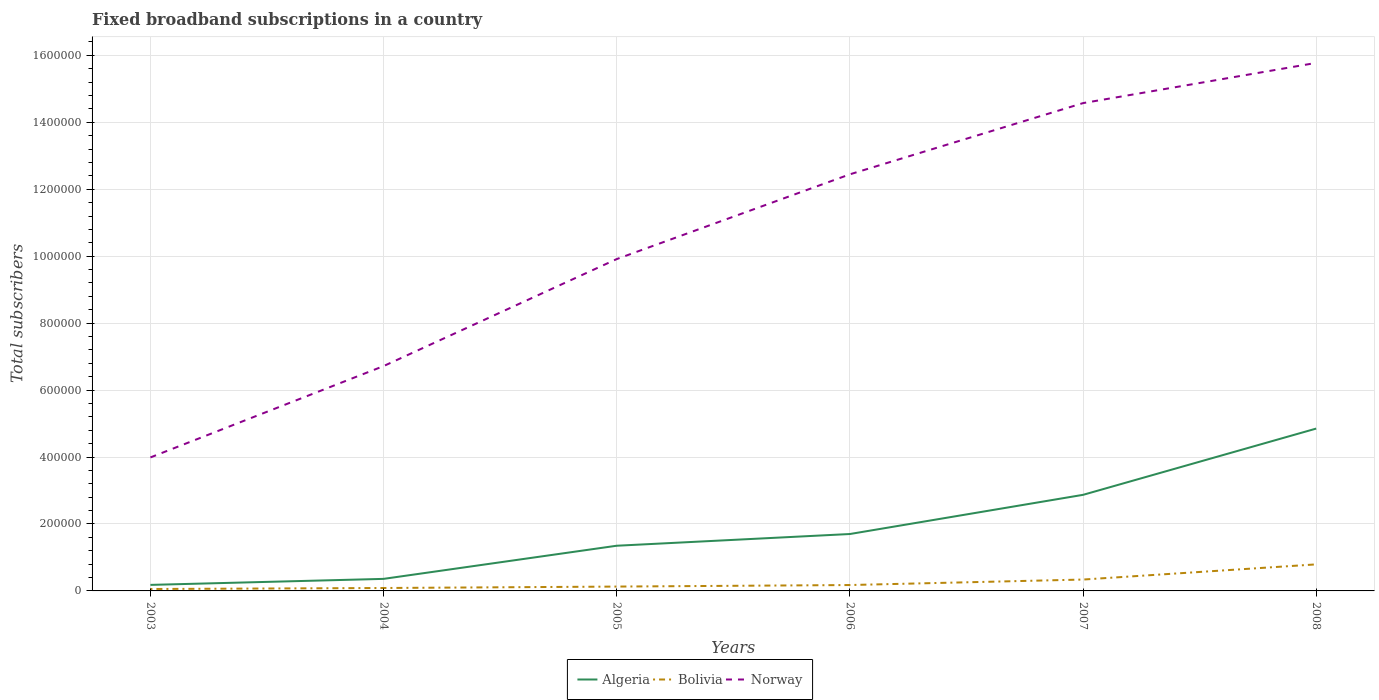Is the number of lines equal to the number of legend labels?
Give a very brief answer. Yes. Across all years, what is the maximum number of broadband subscriptions in Bolivia?
Provide a succinct answer. 5740. What is the total number of broadband subscriptions in Bolivia in the graph?
Provide a short and direct response. -1.18e+04. What is the difference between the highest and the second highest number of broadband subscriptions in Norway?
Provide a succinct answer. 1.18e+06. What is the difference between the highest and the lowest number of broadband subscriptions in Algeria?
Make the answer very short. 2. Is the number of broadband subscriptions in Norway strictly greater than the number of broadband subscriptions in Algeria over the years?
Ensure brevity in your answer.  No. How many years are there in the graph?
Your response must be concise. 6. What is the difference between two consecutive major ticks on the Y-axis?
Ensure brevity in your answer.  2.00e+05. Are the values on the major ticks of Y-axis written in scientific E-notation?
Ensure brevity in your answer.  No. Where does the legend appear in the graph?
Make the answer very short. Bottom center. What is the title of the graph?
Offer a terse response. Fixed broadband subscriptions in a country. What is the label or title of the X-axis?
Keep it short and to the point. Years. What is the label or title of the Y-axis?
Your response must be concise. Total subscribers. What is the Total subscribers of Algeria in 2003?
Ensure brevity in your answer.  1.80e+04. What is the Total subscribers of Bolivia in 2003?
Your response must be concise. 5740. What is the Total subscribers in Norway in 2003?
Your answer should be very brief. 3.99e+05. What is the Total subscribers in Algeria in 2004?
Ensure brevity in your answer.  3.60e+04. What is the Total subscribers of Bolivia in 2004?
Give a very brief answer. 8723. What is the Total subscribers of Norway in 2004?
Your answer should be very brief. 6.72e+05. What is the Total subscribers in Algeria in 2005?
Provide a short and direct response. 1.35e+05. What is the Total subscribers of Bolivia in 2005?
Ensure brevity in your answer.  1.30e+04. What is the Total subscribers in Norway in 2005?
Make the answer very short. 9.91e+05. What is the Total subscribers in Algeria in 2006?
Provide a succinct answer. 1.70e+05. What is the Total subscribers of Bolivia in 2006?
Provide a short and direct response. 1.76e+04. What is the Total subscribers of Norway in 2006?
Make the answer very short. 1.24e+06. What is the Total subscribers of Algeria in 2007?
Ensure brevity in your answer.  2.87e+05. What is the Total subscribers of Bolivia in 2007?
Make the answer very short. 3.40e+04. What is the Total subscribers in Norway in 2007?
Your answer should be very brief. 1.46e+06. What is the Total subscribers of Algeria in 2008?
Your response must be concise. 4.85e+05. What is the Total subscribers in Bolivia in 2008?
Keep it short and to the point. 7.93e+04. What is the Total subscribers in Norway in 2008?
Ensure brevity in your answer.  1.58e+06. Across all years, what is the maximum Total subscribers in Algeria?
Your answer should be compact. 4.85e+05. Across all years, what is the maximum Total subscribers in Bolivia?
Your answer should be compact. 7.93e+04. Across all years, what is the maximum Total subscribers of Norway?
Your answer should be very brief. 1.58e+06. Across all years, what is the minimum Total subscribers of Algeria?
Ensure brevity in your answer.  1.80e+04. Across all years, what is the minimum Total subscribers of Bolivia?
Your response must be concise. 5740. Across all years, what is the minimum Total subscribers of Norway?
Your answer should be compact. 3.99e+05. What is the total Total subscribers of Algeria in the graph?
Provide a short and direct response. 1.13e+06. What is the total Total subscribers in Bolivia in the graph?
Your answer should be compact. 1.58e+05. What is the total Total subscribers in Norway in the graph?
Your answer should be compact. 6.34e+06. What is the difference between the Total subscribers of Algeria in 2003 and that in 2004?
Keep it short and to the point. -1.80e+04. What is the difference between the Total subscribers of Bolivia in 2003 and that in 2004?
Give a very brief answer. -2983. What is the difference between the Total subscribers in Norway in 2003 and that in 2004?
Your answer should be very brief. -2.73e+05. What is the difference between the Total subscribers in Algeria in 2003 and that in 2005?
Your response must be concise. -1.17e+05. What is the difference between the Total subscribers of Bolivia in 2003 and that in 2005?
Provide a succinct answer. -7233. What is the difference between the Total subscribers of Norway in 2003 and that in 2005?
Give a very brief answer. -5.93e+05. What is the difference between the Total subscribers of Algeria in 2003 and that in 2006?
Provide a short and direct response. -1.52e+05. What is the difference between the Total subscribers in Bolivia in 2003 and that in 2006?
Provide a succinct answer. -1.18e+04. What is the difference between the Total subscribers of Norway in 2003 and that in 2006?
Provide a short and direct response. -8.46e+05. What is the difference between the Total subscribers of Algeria in 2003 and that in 2007?
Ensure brevity in your answer.  -2.69e+05. What is the difference between the Total subscribers in Bolivia in 2003 and that in 2007?
Provide a succinct answer. -2.82e+04. What is the difference between the Total subscribers in Norway in 2003 and that in 2007?
Offer a terse response. -1.06e+06. What is the difference between the Total subscribers in Algeria in 2003 and that in 2008?
Give a very brief answer. -4.67e+05. What is the difference between the Total subscribers of Bolivia in 2003 and that in 2008?
Your answer should be very brief. -7.36e+04. What is the difference between the Total subscribers in Norway in 2003 and that in 2008?
Keep it short and to the point. -1.18e+06. What is the difference between the Total subscribers in Algeria in 2004 and that in 2005?
Make the answer very short. -9.90e+04. What is the difference between the Total subscribers in Bolivia in 2004 and that in 2005?
Ensure brevity in your answer.  -4250. What is the difference between the Total subscribers of Norway in 2004 and that in 2005?
Your answer should be compact. -3.20e+05. What is the difference between the Total subscribers of Algeria in 2004 and that in 2006?
Offer a very short reply. -1.34e+05. What is the difference between the Total subscribers in Bolivia in 2004 and that in 2006?
Give a very brief answer. -8866. What is the difference between the Total subscribers of Norway in 2004 and that in 2006?
Keep it short and to the point. -5.73e+05. What is the difference between the Total subscribers in Algeria in 2004 and that in 2007?
Ensure brevity in your answer.  -2.51e+05. What is the difference between the Total subscribers in Bolivia in 2004 and that in 2007?
Ensure brevity in your answer.  -2.53e+04. What is the difference between the Total subscribers of Norway in 2004 and that in 2007?
Provide a short and direct response. -7.86e+05. What is the difference between the Total subscribers in Algeria in 2004 and that in 2008?
Provide a succinct answer. -4.49e+05. What is the difference between the Total subscribers in Bolivia in 2004 and that in 2008?
Provide a short and direct response. -7.06e+04. What is the difference between the Total subscribers in Norway in 2004 and that in 2008?
Your response must be concise. -9.06e+05. What is the difference between the Total subscribers of Algeria in 2005 and that in 2006?
Make the answer very short. -3.50e+04. What is the difference between the Total subscribers of Bolivia in 2005 and that in 2006?
Your answer should be very brief. -4616. What is the difference between the Total subscribers in Norway in 2005 and that in 2006?
Your answer should be compact. -2.53e+05. What is the difference between the Total subscribers of Algeria in 2005 and that in 2007?
Keep it short and to the point. -1.52e+05. What is the difference between the Total subscribers of Bolivia in 2005 and that in 2007?
Your answer should be compact. -2.10e+04. What is the difference between the Total subscribers of Norway in 2005 and that in 2007?
Give a very brief answer. -4.66e+05. What is the difference between the Total subscribers of Algeria in 2005 and that in 2008?
Your answer should be compact. -3.50e+05. What is the difference between the Total subscribers of Bolivia in 2005 and that in 2008?
Offer a terse response. -6.63e+04. What is the difference between the Total subscribers in Norway in 2005 and that in 2008?
Offer a very short reply. -5.86e+05. What is the difference between the Total subscribers in Algeria in 2006 and that in 2007?
Make the answer very short. -1.17e+05. What is the difference between the Total subscribers of Bolivia in 2006 and that in 2007?
Your response must be concise. -1.64e+04. What is the difference between the Total subscribers in Norway in 2006 and that in 2007?
Make the answer very short. -2.13e+05. What is the difference between the Total subscribers of Algeria in 2006 and that in 2008?
Offer a very short reply. -3.15e+05. What is the difference between the Total subscribers in Bolivia in 2006 and that in 2008?
Make the answer very short. -6.17e+04. What is the difference between the Total subscribers in Norway in 2006 and that in 2008?
Provide a short and direct response. -3.33e+05. What is the difference between the Total subscribers of Algeria in 2007 and that in 2008?
Ensure brevity in your answer.  -1.98e+05. What is the difference between the Total subscribers of Bolivia in 2007 and that in 2008?
Keep it short and to the point. -4.53e+04. What is the difference between the Total subscribers in Norway in 2007 and that in 2008?
Keep it short and to the point. -1.20e+05. What is the difference between the Total subscribers in Algeria in 2003 and the Total subscribers in Bolivia in 2004?
Your answer should be compact. 9277. What is the difference between the Total subscribers in Algeria in 2003 and the Total subscribers in Norway in 2004?
Offer a terse response. -6.54e+05. What is the difference between the Total subscribers of Bolivia in 2003 and the Total subscribers of Norway in 2004?
Your answer should be compact. -6.66e+05. What is the difference between the Total subscribers of Algeria in 2003 and the Total subscribers of Bolivia in 2005?
Offer a very short reply. 5027. What is the difference between the Total subscribers in Algeria in 2003 and the Total subscribers in Norway in 2005?
Give a very brief answer. -9.73e+05. What is the difference between the Total subscribers of Bolivia in 2003 and the Total subscribers of Norway in 2005?
Provide a succinct answer. -9.86e+05. What is the difference between the Total subscribers of Algeria in 2003 and the Total subscribers of Bolivia in 2006?
Keep it short and to the point. 411. What is the difference between the Total subscribers in Algeria in 2003 and the Total subscribers in Norway in 2006?
Offer a very short reply. -1.23e+06. What is the difference between the Total subscribers in Bolivia in 2003 and the Total subscribers in Norway in 2006?
Your answer should be very brief. -1.24e+06. What is the difference between the Total subscribers in Algeria in 2003 and the Total subscribers in Bolivia in 2007?
Provide a short and direct response. -1.60e+04. What is the difference between the Total subscribers in Algeria in 2003 and the Total subscribers in Norway in 2007?
Give a very brief answer. -1.44e+06. What is the difference between the Total subscribers in Bolivia in 2003 and the Total subscribers in Norway in 2007?
Your response must be concise. -1.45e+06. What is the difference between the Total subscribers in Algeria in 2003 and the Total subscribers in Bolivia in 2008?
Offer a terse response. -6.13e+04. What is the difference between the Total subscribers in Algeria in 2003 and the Total subscribers in Norway in 2008?
Your answer should be compact. -1.56e+06. What is the difference between the Total subscribers of Bolivia in 2003 and the Total subscribers of Norway in 2008?
Ensure brevity in your answer.  -1.57e+06. What is the difference between the Total subscribers in Algeria in 2004 and the Total subscribers in Bolivia in 2005?
Offer a terse response. 2.30e+04. What is the difference between the Total subscribers of Algeria in 2004 and the Total subscribers of Norway in 2005?
Offer a terse response. -9.55e+05. What is the difference between the Total subscribers of Bolivia in 2004 and the Total subscribers of Norway in 2005?
Keep it short and to the point. -9.83e+05. What is the difference between the Total subscribers of Algeria in 2004 and the Total subscribers of Bolivia in 2006?
Offer a very short reply. 1.84e+04. What is the difference between the Total subscribers of Algeria in 2004 and the Total subscribers of Norway in 2006?
Make the answer very short. -1.21e+06. What is the difference between the Total subscribers in Bolivia in 2004 and the Total subscribers in Norway in 2006?
Offer a very short reply. -1.24e+06. What is the difference between the Total subscribers of Algeria in 2004 and the Total subscribers of Bolivia in 2007?
Your response must be concise. 2023. What is the difference between the Total subscribers in Algeria in 2004 and the Total subscribers in Norway in 2007?
Keep it short and to the point. -1.42e+06. What is the difference between the Total subscribers of Bolivia in 2004 and the Total subscribers of Norway in 2007?
Offer a very short reply. -1.45e+06. What is the difference between the Total subscribers in Algeria in 2004 and the Total subscribers in Bolivia in 2008?
Offer a very short reply. -4.33e+04. What is the difference between the Total subscribers in Algeria in 2004 and the Total subscribers in Norway in 2008?
Your answer should be very brief. -1.54e+06. What is the difference between the Total subscribers of Bolivia in 2004 and the Total subscribers of Norway in 2008?
Provide a succinct answer. -1.57e+06. What is the difference between the Total subscribers of Algeria in 2005 and the Total subscribers of Bolivia in 2006?
Give a very brief answer. 1.17e+05. What is the difference between the Total subscribers in Algeria in 2005 and the Total subscribers in Norway in 2006?
Make the answer very short. -1.11e+06. What is the difference between the Total subscribers in Bolivia in 2005 and the Total subscribers in Norway in 2006?
Keep it short and to the point. -1.23e+06. What is the difference between the Total subscribers of Algeria in 2005 and the Total subscribers of Bolivia in 2007?
Your response must be concise. 1.01e+05. What is the difference between the Total subscribers of Algeria in 2005 and the Total subscribers of Norway in 2007?
Give a very brief answer. -1.32e+06. What is the difference between the Total subscribers of Bolivia in 2005 and the Total subscribers of Norway in 2007?
Your answer should be very brief. -1.44e+06. What is the difference between the Total subscribers in Algeria in 2005 and the Total subscribers in Bolivia in 2008?
Ensure brevity in your answer.  5.57e+04. What is the difference between the Total subscribers of Algeria in 2005 and the Total subscribers of Norway in 2008?
Provide a short and direct response. -1.44e+06. What is the difference between the Total subscribers of Bolivia in 2005 and the Total subscribers of Norway in 2008?
Ensure brevity in your answer.  -1.56e+06. What is the difference between the Total subscribers of Algeria in 2006 and the Total subscribers of Bolivia in 2007?
Give a very brief answer. 1.36e+05. What is the difference between the Total subscribers of Algeria in 2006 and the Total subscribers of Norway in 2007?
Give a very brief answer. -1.29e+06. What is the difference between the Total subscribers in Bolivia in 2006 and the Total subscribers in Norway in 2007?
Keep it short and to the point. -1.44e+06. What is the difference between the Total subscribers of Algeria in 2006 and the Total subscribers of Bolivia in 2008?
Your answer should be very brief. 9.07e+04. What is the difference between the Total subscribers of Algeria in 2006 and the Total subscribers of Norway in 2008?
Your answer should be very brief. -1.41e+06. What is the difference between the Total subscribers of Bolivia in 2006 and the Total subscribers of Norway in 2008?
Your answer should be very brief. -1.56e+06. What is the difference between the Total subscribers of Algeria in 2007 and the Total subscribers of Bolivia in 2008?
Keep it short and to the point. 2.08e+05. What is the difference between the Total subscribers in Algeria in 2007 and the Total subscribers in Norway in 2008?
Keep it short and to the point. -1.29e+06. What is the difference between the Total subscribers in Bolivia in 2007 and the Total subscribers in Norway in 2008?
Provide a succinct answer. -1.54e+06. What is the average Total subscribers in Algeria per year?
Provide a succinct answer. 1.89e+05. What is the average Total subscribers in Bolivia per year?
Make the answer very short. 2.64e+04. What is the average Total subscribers in Norway per year?
Keep it short and to the point. 1.06e+06. In the year 2003, what is the difference between the Total subscribers of Algeria and Total subscribers of Bolivia?
Offer a very short reply. 1.23e+04. In the year 2003, what is the difference between the Total subscribers of Algeria and Total subscribers of Norway?
Your response must be concise. -3.81e+05. In the year 2003, what is the difference between the Total subscribers of Bolivia and Total subscribers of Norway?
Offer a terse response. -3.93e+05. In the year 2004, what is the difference between the Total subscribers of Algeria and Total subscribers of Bolivia?
Your answer should be very brief. 2.73e+04. In the year 2004, what is the difference between the Total subscribers in Algeria and Total subscribers in Norway?
Your answer should be very brief. -6.36e+05. In the year 2004, what is the difference between the Total subscribers in Bolivia and Total subscribers in Norway?
Keep it short and to the point. -6.63e+05. In the year 2005, what is the difference between the Total subscribers in Algeria and Total subscribers in Bolivia?
Give a very brief answer. 1.22e+05. In the year 2005, what is the difference between the Total subscribers in Algeria and Total subscribers in Norway?
Ensure brevity in your answer.  -8.56e+05. In the year 2005, what is the difference between the Total subscribers in Bolivia and Total subscribers in Norway?
Provide a short and direct response. -9.78e+05. In the year 2006, what is the difference between the Total subscribers of Algeria and Total subscribers of Bolivia?
Make the answer very short. 1.52e+05. In the year 2006, what is the difference between the Total subscribers in Algeria and Total subscribers in Norway?
Your answer should be very brief. -1.07e+06. In the year 2006, what is the difference between the Total subscribers in Bolivia and Total subscribers in Norway?
Your answer should be compact. -1.23e+06. In the year 2007, what is the difference between the Total subscribers in Algeria and Total subscribers in Bolivia?
Your response must be concise. 2.53e+05. In the year 2007, what is the difference between the Total subscribers of Algeria and Total subscribers of Norway?
Your response must be concise. -1.17e+06. In the year 2007, what is the difference between the Total subscribers in Bolivia and Total subscribers in Norway?
Provide a short and direct response. -1.42e+06. In the year 2008, what is the difference between the Total subscribers in Algeria and Total subscribers in Bolivia?
Make the answer very short. 4.06e+05. In the year 2008, what is the difference between the Total subscribers of Algeria and Total subscribers of Norway?
Offer a terse response. -1.09e+06. In the year 2008, what is the difference between the Total subscribers of Bolivia and Total subscribers of Norway?
Your response must be concise. -1.50e+06. What is the ratio of the Total subscribers in Algeria in 2003 to that in 2004?
Your answer should be very brief. 0.5. What is the ratio of the Total subscribers of Bolivia in 2003 to that in 2004?
Offer a very short reply. 0.66. What is the ratio of the Total subscribers in Norway in 2003 to that in 2004?
Ensure brevity in your answer.  0.59. What is the ratio of the Total subscribers in Algeria in 2003 to that in 2005?
Give a very brief answer. 0.13. What is the ratio of the Total subscribers in Bolivia in 2003 to that in 2005?
Your answer should be compact. 0.44. What is the ratio of the Total subscribers of Norway in 2003 to that in 2005?
Ensure brevity in your answer.  0.4. What is the ratio of the Total subscribers of Algeria in 2003 to that in 2006?
Offer a very short reply. 0.11. What is the ratio of the Total subscribers in Bolivia in 2003 to that in 2006?
Offer a terse response. 0.33. What is the ratio of the Total subscribers in Norway in 2003 to that in 2006?
Your response must be concise. 0.32. What is the ratio of the Total subscribers in Algeria in 2003 to that in 2007?
Keep it short and to the point. 0.06. What is the ratio of the Total subscribers in Bolivia in 2003 to that in 2007?
Your answer should be very brief. 0.17. What is the ratio of the Total subscribers of Norway in 2003 to that in 2007?
Your answer should be very brief. 0.27. What is the ratio of the Total subscribers of Algeria in 2003 to that in 2008?
Give a very brief answer. 0.04. What is the ratio of the Total subscribers in Bolivia in 2003 to that in 2008?
Provide a short and direct response. 0.07. What is the ratio of the Total subscribers in Norway in 2003 to that in 2008?
Your answer should be compact. 0.25. What is the ratio of the Total subscribers in Algeria in 2004 to that in 2005?
Make the answer very short. 0.27. What is the ratio of the Total subscribers of Bolivia in 2004 to that in 2005?
Provide a succinct answer. 0.67. What is the ratio of the Total subscribers in Norway in 2004 to that in 2005?
Provide a succinct answer. 0.68. What is the ratio of the Total subscribers of Algeria in 2004 to that in 2006?
Keep it short and to the point. 0.21. What is the ratio of the Total subscribers in Bolivia in 2004 to that in 2006?
Your answer should be compact. 0.5. What is the ratio of the Total subscribers in Norway in 2004 to that in 2006?
Ensure brevity in your answer.  0.54. What is the ratio of the Total subscribers in Algeria in 2004 to that in 2007?
Offer a terse response. 0.13. What is the ratio of the Total subscribers in Bolivia in 2004 to that in 2007?
Your response must be concise. 0.26. What is the ratio of the Total subscribers of Norway in 2004 to that in 2007?
Your answer should be compact. 0.46. What is the ratio of the Total subscribers in Algeria in 2004 to that in 2008?
Provide a succinct answer. 0.07. What is the ratio of the Total subscribers in Bolivia in 2004 to that in 2008?
Offer a terse response. 0.11. What is the ratio of the Total subscribers in Norway in 2004 to that in 2008?
Your response must be concise. 0.43. What is the ratio of the Total subscribers of Algeria in 2005 to that in 2006?
Keep it short and to the point. 0.79. What is the ratio of the Total subscribers in Bolivia in 2005 to that in 2006?
Make the answer very short. 0.74. What is the ratio of the Total subscribers in Norway in 2005 to that in 2006?
Give a very brief answer. 0.8. What is the ratio of the Total subscribers of Algeria in 2005 to that in 2007?
Provide a succinct answer. 0.47. What is the ratio of the Total subscribers in Bolivia in 2005 to that in 2007?
Your answer should be compact. 0.38. What is the ratio of the Total subscribers in Norway in 2005 to that in 2007?
Give a very brief answer. 0.68. What is the ratio of the Total subscribers in Algeria in 2005 to that in 2008?
Offer a very short reply. 0.28. What is the ratio of the Total subscribers of Bolivia in 2005 to that in 2008?
Give a very brief answer. 0.16. What is the ratio of the Total subscribers in Norway in 2005 to that in 2008?
Give a very brief answer. 0.63. What is the ratio of the Total subscribers of Algeria in 2006 to that in 2007?
Your response must be concise. 0.59. What is the ratio of the Total subscribers of Bolivia in 2006 to that in 2007?
Your answer should be compact. 0.52. What is the ratio of the Total subscribers in Norway in 2006 to that in 2007?
Offer a very short reply. 0.85. What is the ratio of the Total subscribers in Algeria in 2006 to that in 2008?
Offer a terse response. 0.35. What is the ratio of the Total subscribers in Bolivia in 2006 to that in 2008?
Your response must be concise. 0.22. What is the ratio of the Total subscribers of Norway in 2006 to that in 2008?
Your answer should be compact. 0.79. What is the ratio of the Total subscribers of Algeria in 2007 to that in 2008?
Your answer should be very brief. 0.59. What is the ratio of the Total subscribers of Bolivia in 2007 to that in 2008?
Provide a short and direct response. 0.43. What is the ratio of the Total subscribers in Norway in 2007 to that in 2008?
Ensure brevity in your answer.  0.92. What is the difference between the highest and the second highest Total subscribers of Algeria?
Keep it short and to the point. 1.98e+05. What is the difference between the highest and the second highest Total subscribers in Bolivia?
Provide a short and direct response. 4.53e+04. What is the difference between the highest and the second highest Total subscribers of Norway?
Ensure brevity in your answer.  1.20e+05. What is the difference between the highest and the lowest Total subscribers in Algeria?
Make the answer very short. 4.67e+05. What is the difference between the highest and the lowest Total subscribers of Bolivia?
Keep it short and to the point. 7.36e+04. What is the difference between the highest and the lowest Total subscribers in Norway?
Ensure brevity in your answer.  1.18e+06. 